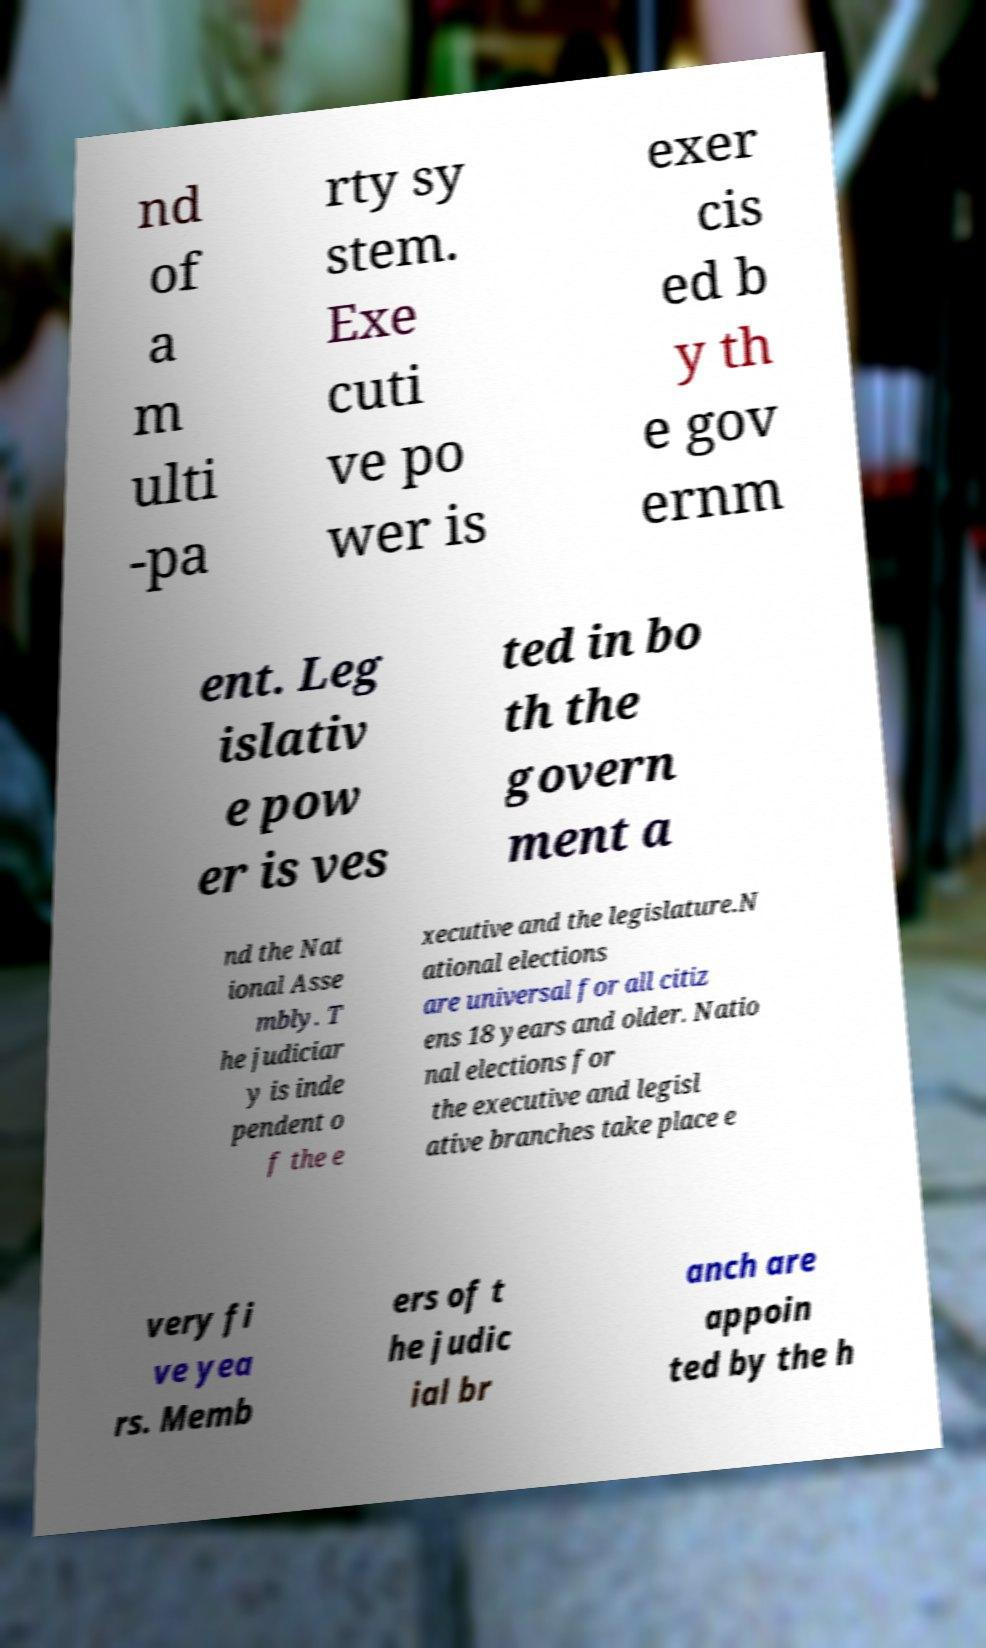Can you accurately transcribe the text from the provided image for me? nd of a m ulti -pa rty sy stem. Exe cuti ve po wer is exer cis ed b y th e gov ernm ent. Leg islativ e pow er is ves ted in bo th the govern ment a nd the Nat ional Asse mbly. T he judiciar y is inde pendent o f the e xecutive and the legislature.N ational elections are universal for all citiz ens 18 years and older. Natio nal elections for the executive and legisl ative branches take place e very fi ve yea rs. Memb ers of t he judic ial br anch are appoin ted by the h 